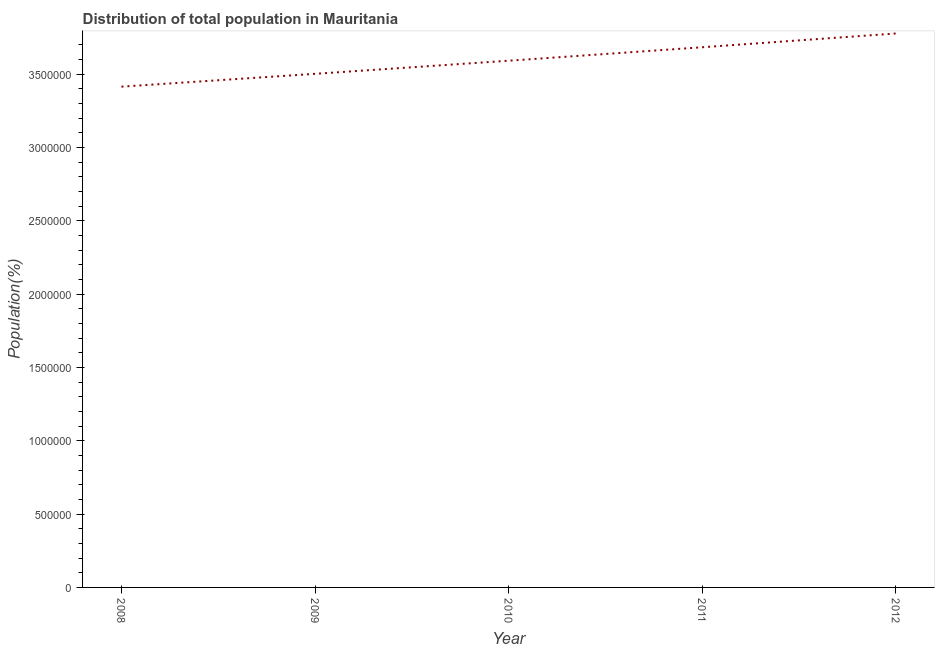What is the population in 2008?
Keep it short and to the point. 3.41e+06. Across all years, what is the maximum population?
Offer a very short reply. 3.78e+06. Across all years, what is the minimum population?
Your response must be concise. 3.41e+06. In which year was the population minimum?
Offer a terse response. 2008. What is the sum of the population?
Your response must be concise. 1.80e+07. What is the difference between the population in 2008 and 2011?
Make the answer very short. -2.69e+05. What is the average population per year?
Ensure brevity in your answer.  3.59e+06. What is the median population?
Provide a short and direct response. 3.59e+06. In how many years, is the population greater than 300000 %?
Provide a short and direct response. 5. What is the ratio of the population in 2009 to that in 2011?
Offer a terse response. 0.95. What is the difference between the highest and the second highest population?
Ensure brevity in your answer.  9.38e+04. What is the difference between the highest and the lowest population?
Offer a terse response. 3.63e+05. In how many years, is the population greater than the average population taken over all years?
Offer a terse response. 2. Does the population monotonically increase over the years?
Offer a terse response. Yes. How many lines are there?
Ensure brevity in your answer.  1. How many years are there in the graph?
Provide a short and direct response. 5. What is the difference between two consecutive major ticks on the Y-axis?
Your answer should be very brief. 5.00e+05. Are the values on the major ticks of Y-axis written in scientific E-notation?
Offer a very short reply. No. Does the graph contain any zero values?
Provide a short and direct response. No. Does the graph contain grids?
Your answer should be compact. No. What is the title of the graph?
Your answer should be very brief. Distribution of total population in Mauritania . What is the label or title of the Y-axis?
Give a very brief answer. Population(%). What is the Population(%) of 2008?
Keep it short and to the point. 3.41e+06. What is the Population(%) of 2009?
Your response must be concise. 3.50e+06. What is the Population(%) in 2010?
Your response must be concise. 3.59e+06. What is the Population(%) in 2011?
Provide a short and direct response. 3.68e+06. What is the Population(%) in 2012?
Your answer should be compact. 3.78e+06. What is the difference between the Population(%) in 2008 and 2009?
Your response must be concise. -8.74e+04. What is the difference between the Population(%) in 2008 and 2010?
Your answer should be compact. -1.77e+05. What is the difference between the Population(%) in 2008 and 2011?
Provide a succinct answer. -2.69e+05. What is the difference between the Population(%) in 2008 and 2012?
Keep it short and to the point. -3.63e+05. What is the difference between the Population(%) in 2009 and 2010?
Offer a terse response. -8.95e+04. What is the difference between the Population(%) in 2009 and 2011?
Keep it short and to the point. -1.81e+05. What is the difference between the Population(%) in 2009 and 2012?
Your response must be concise. -2.75e+05. What is the difference between the Population(%) in 2010 and 2011?
Ensure brevity in your answer.  -9.18e+04. What is the difference between the Population(%) in 2010 and 2012?
Your answer should be very brief. -1.86e+05. What is the difference between the Population(%) in 2011 and 2012?
Offer a very short reply. -9.38e+04. What is the ratio of the Population(%) in 2008 to that in 2010?
Your answer should be very brief. 0.95. What is the ratio of the Population(%) in 2008 to that in 2011?
Provide a short and direct response. 0.93. What is the ratio of the Population(%) in 2008 to that in 2012?
Give a very brief answer. 0.9. What is the ratio of the Population(%) in 2009 to that in 2010?
Make the answer very short. 0.97. What is the ratio of the Population(%) in 2009 to that in 2011?
Offer a very short reply. 0.95. What is the ratio of the Population(%) in 2009 to that in 2012?
Provide a short and direct response. 0.93. What is the ratio of the Population(%) in 2010 to that in 2011?
Your answer should be very brief. 0.97. What is the ratio of the Population(%) in 2010 to that in 2012?
Your answer should be very brief. 0.95. 